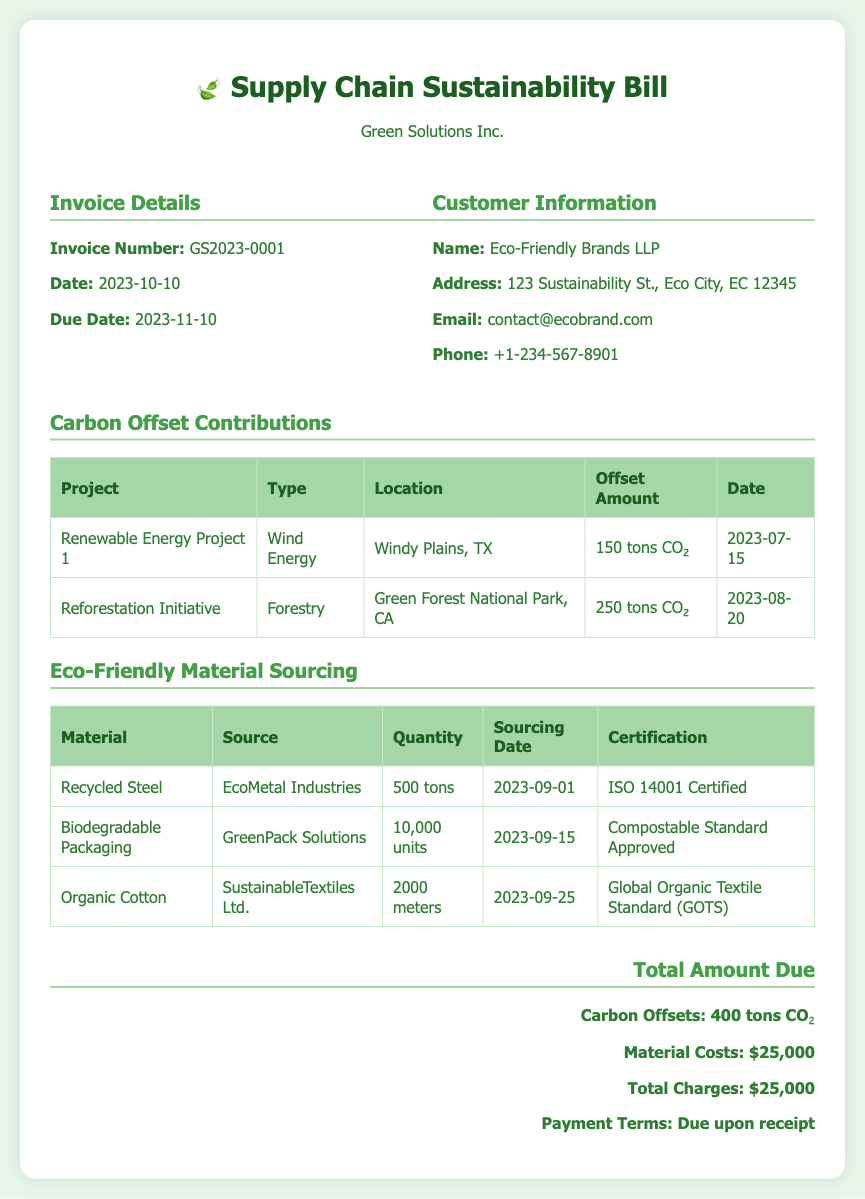What is the invoice number? The invoice number is mentioned in the Invoice Details section of the document as GS2023-0001.
Answer: GS2023-0001 What is the due date for payment? The due date for payment is specified in the Invoice Details section as 2023-11-10.
Answer: 2023-11-10 How many tons of CO₂ are offset by the Renewable Energy Project 1? The offset amount for the Renewable Energy Project 1 is listed in the Carbon Offset Contributions table as 150 tons CO₂.
Answer: 150 tons CO₂ What is the quantity of biodegradable packaging sourced? The quantity of biodegradable packaging is indicated in the Eco-Friendly Material Sourcing table as 10,000 units.
Answer: 10,000 units Which material is sourced from EcoMetal Industries? The material sourced from EcoMetal Industries is found in the Eco-Friendly Material Sourcing table as Recycled Steel.
Answer: Recycled Steel What total amount is due according to the document? The total amount due is stated in the Total Amount Due section as $25,000.
Answer: $25,000 What is the certification for Organic Cotton? The certification for Organic Cotton is specified in the Eco-Friendly Material Sourcing table as Global Organic Textile Standard (GOTS).
Answer: Global Organic Textile Standard (GOTS) Which project contributes the most CO₂ offset? The project contributing the most CO₂ offset is found in the Carbon Offset Contributions table, which is the Reforestation Initiative at 250 tons CO₂.
Answer: Reforestation Initiative What type of energy is associated with Renewable Energy Project 1? The type of energy associated with Renewable Energy Project 1 is mentioned as Wind Energy in the Carbon Offset Contributions table.
Answer: Wind Energy 